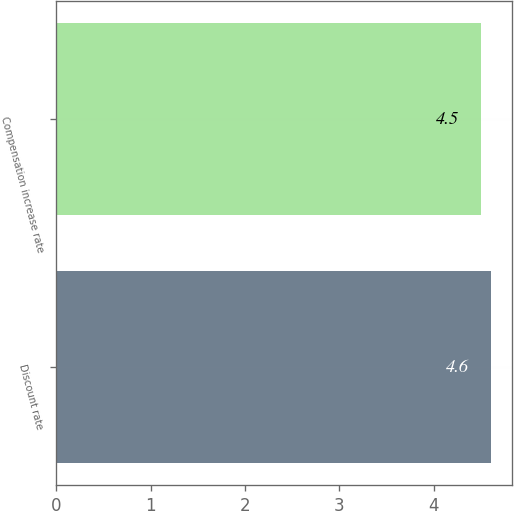Convert chart to OTSL. <chart><loc_0><loc_0><loc_500><loc_500><bar_chart><fcel>Discount rate<fcel>Compensation increase rate<nl><fcel>4.6<fcel>4.5<nl></chart> 